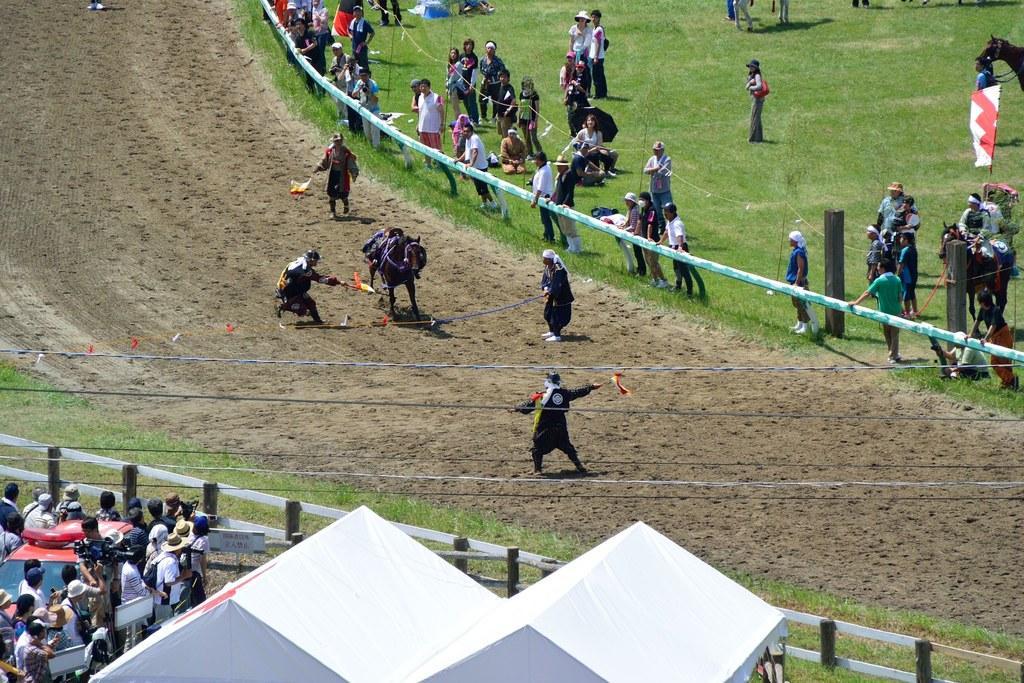Please provide a concise description of this image. In this image we can see race ground. To the both sides of the ground fencing is there and people are standing and watching. In the ground one animal is there. Around the animal four person are standing. Bottom of the image white color shelter is present. 